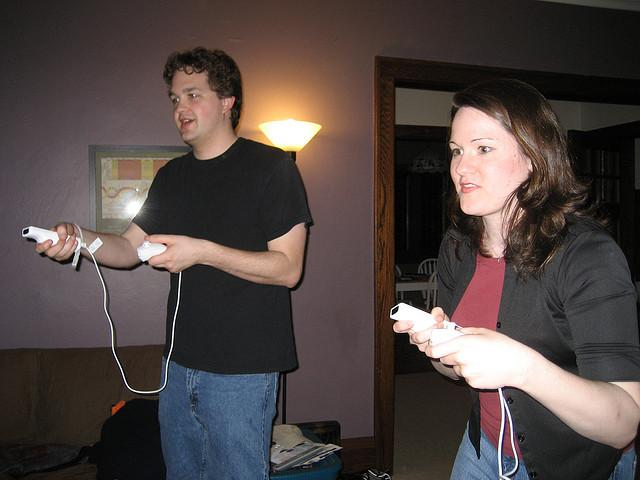What video game system are they playing?

Choices:
A) nintendo switch
B) x box
C) wii
D) playstation wii 